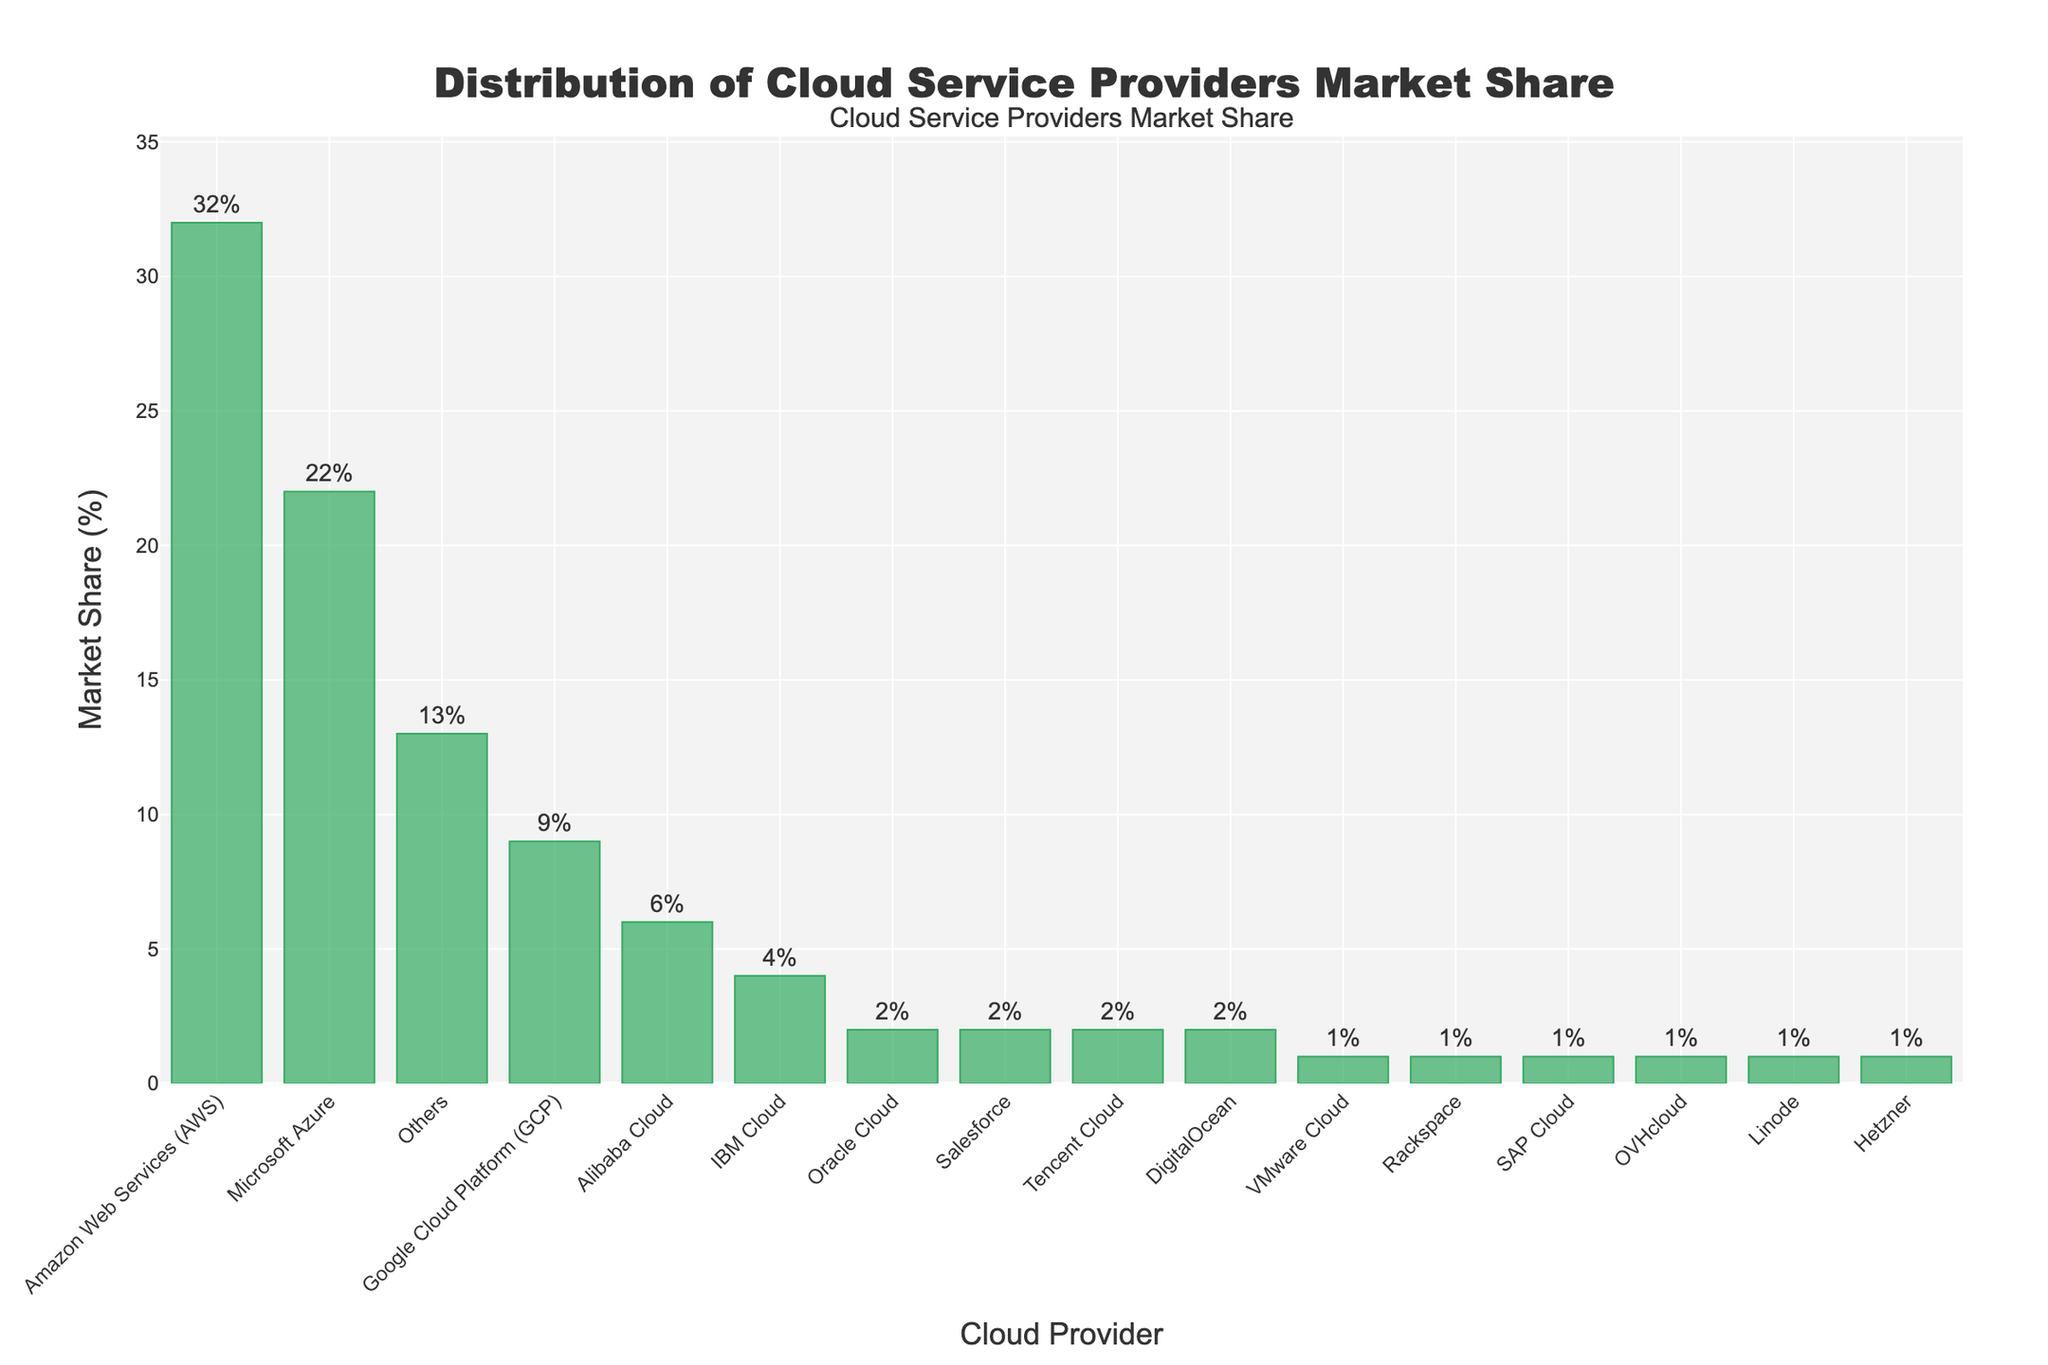What is the market share of Amazon Web Services (AWS)? Look at the bar labeled "Amazon Web Services (AWS)" and read the value indicated above the bar.
Answer: 32% Which cloud service provider has the lowest market share? Identify the shortest bar in the chart and read its corresponding label. Multiple providers, including VMware Cloud, Rackspace, SAP Cloud, OVHcloud, Linode, and Hetzner, each have the shortest bar.
Answer: VMware Cloud, Rackspace, SAP Cloud, OVHcloud, Linode, Hetzner What is the difference in market share between Amazon Web Services (AWS) and Microsoft Azure? Find the bar heights for AWS and Microsoft Azure. AWS is 32%, and Microsoft Azure is 22%. Subtract the Azure market share from the AWS market share: 32% - 22% = 10%.
Answer: 10% What is the combined market share of Oracle Cloud, Salesforce, and Tencent Cloud? Locate the bars for Oracle Cloud, Salesforce, and Tencent Cloud. Oracle Cloud is 2%, Salesforce is 2%, and Tencent Cloud is 2%. Add them together: 2% + 2% + 2% = 6%.
Answer: 6% How does the market share of Alibaba Cloud compare to that of Google Cloud Platform (GCP)? Find the bars for Alibaba Cloud and Google Cloud Platform (GCP). Alibaba Cloud has 6%, and GCP has 9%. Compare them: 6% is less than 9%.
Answer: Alibaba Cloud's market share is less than GCP's Among the providers with a market share of 2%, which ones are included? Identify the bars that are labeled with a market share of 2%. These are Oracle Cloud, Salesforce, Tencent Cloud, and DigitalOcean.
Answer: Oracle Cloud, Salesforce, Tencent Cloud, DigitalOcean What is the total market share of the top three cloud providers? Find the market shares of the top three providers (the three tallest bars): AWS (32%), Microsoft Azure (22%), and Google Cloud Platform (GCP) (9%). Add them together: 32% + 22% + 9% = 63%.
Answer: 63% What fraction of the total market is held by the largest provider, Amazon Web Services (AWS)? AWS has a market share of 32%. The total market share sums up to 100%. Thus, AWS holds 32/100, which simplifies to 32%.
Answer: 32% Between IBM Cloud and Others, which holds a greater market share and by how much? Find the market shares for IBM Cloud (4%) and Others (13%). Subtract IBM Cloud's market share from that of Others: 13% - 4% = 9%.
Answer: Others holds a greater market share by 9% What is the median market share value among all cloud providers listed? Arrange all market share values in ascending order to find the median: 1%, 1%, 1%, 1%, 1%, 2%, 2%, 2%, 2%, 4%, 6%, 9%, 13%, 22%, 32%. The middle value of this ordered list is 2% (8th position in a list of 15 values).
Answer: 2% 